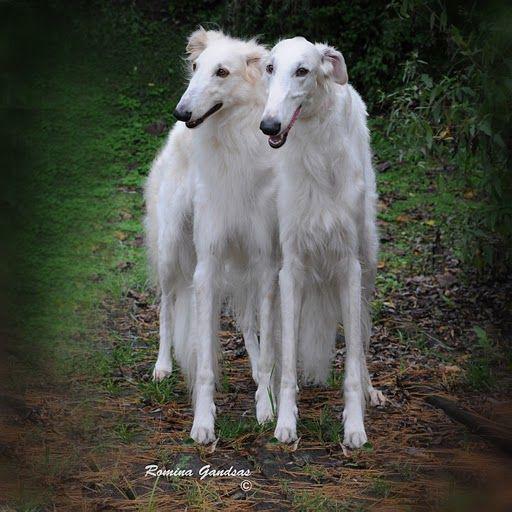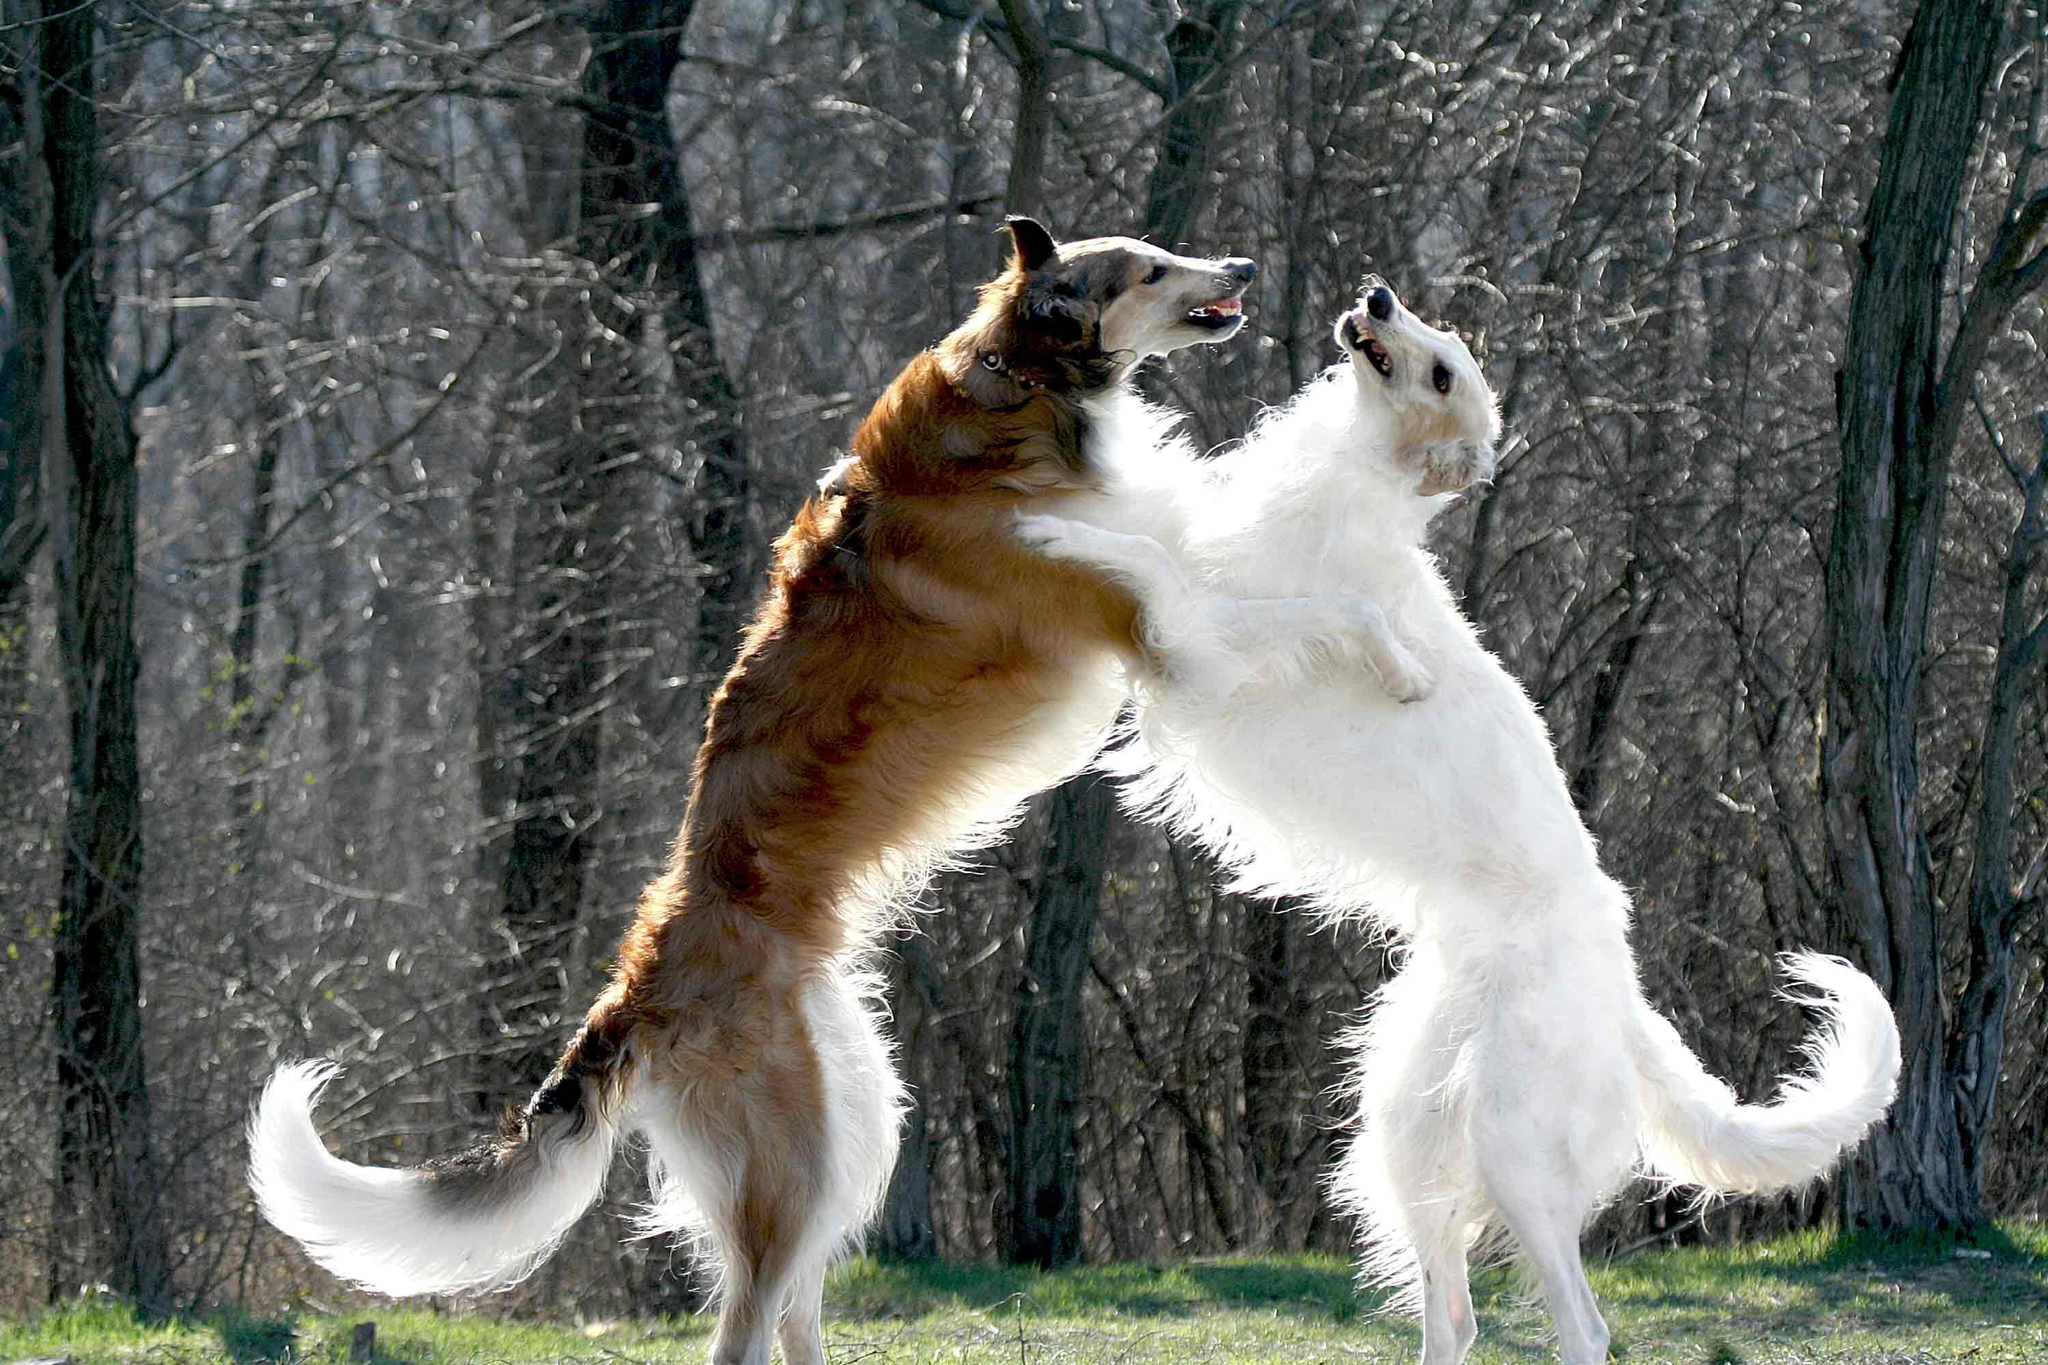The first image is the image on the left, the second image is the image on the right. Analyze the images presented: Is the assertion "Each image shows one hound standing outdoors." valid? Answer yes or no. No. The first image is the image on the left, the second image is the image on the right. Considering the images on both sides, is "There are 2 dogs standing on grass." valid? Answer yes or no. No. 